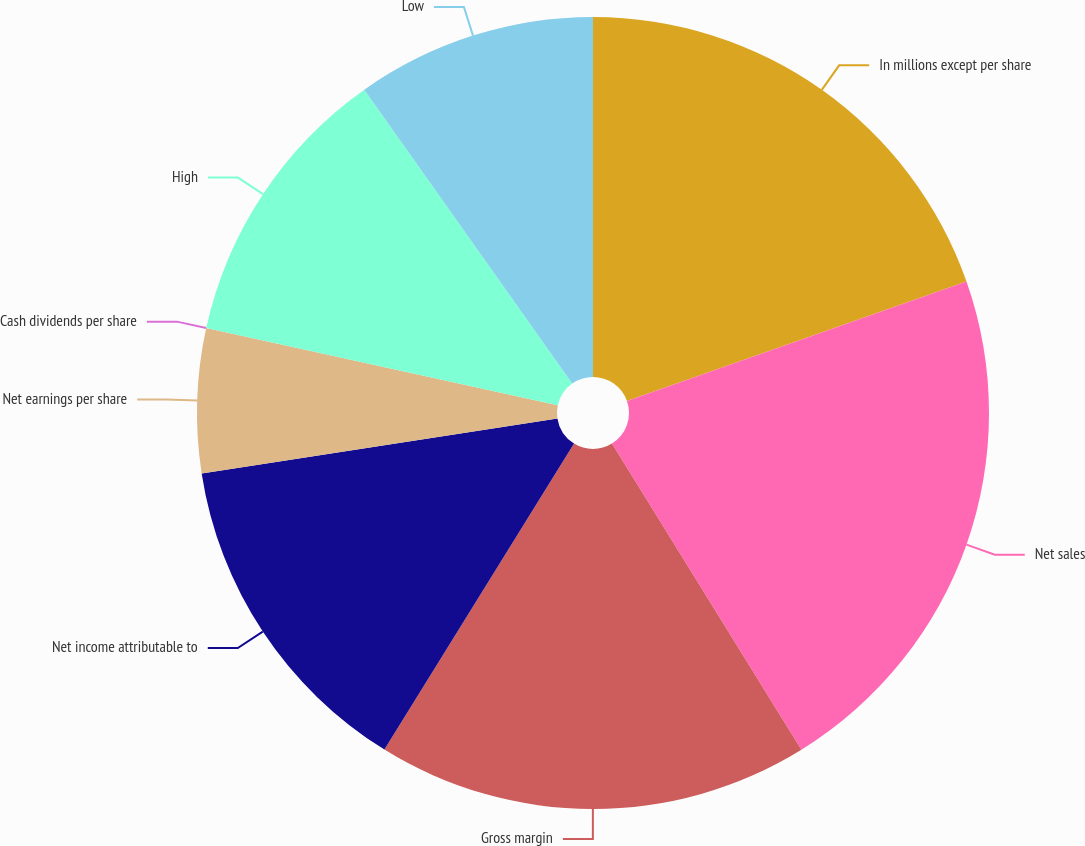Convert chart to OTSL. <chart><loc_0><loc_0><loc_500><loc_500><pie_chart><fcel>In millions except per share<fcel>Net sales<fcel>Gross margin<fcel>Net income attributable to<fcel>Net earnings per share<fcel>Cash dividends per share<fcel>High<fcel>Low<nl><fcel>19.61%<fcel>21.57%<fcel>17.65%<fcel>13.73%<fcel>5.88%<fcel>0.0%<fcel>11.76%<fcel>9.8%<nl></chart> 